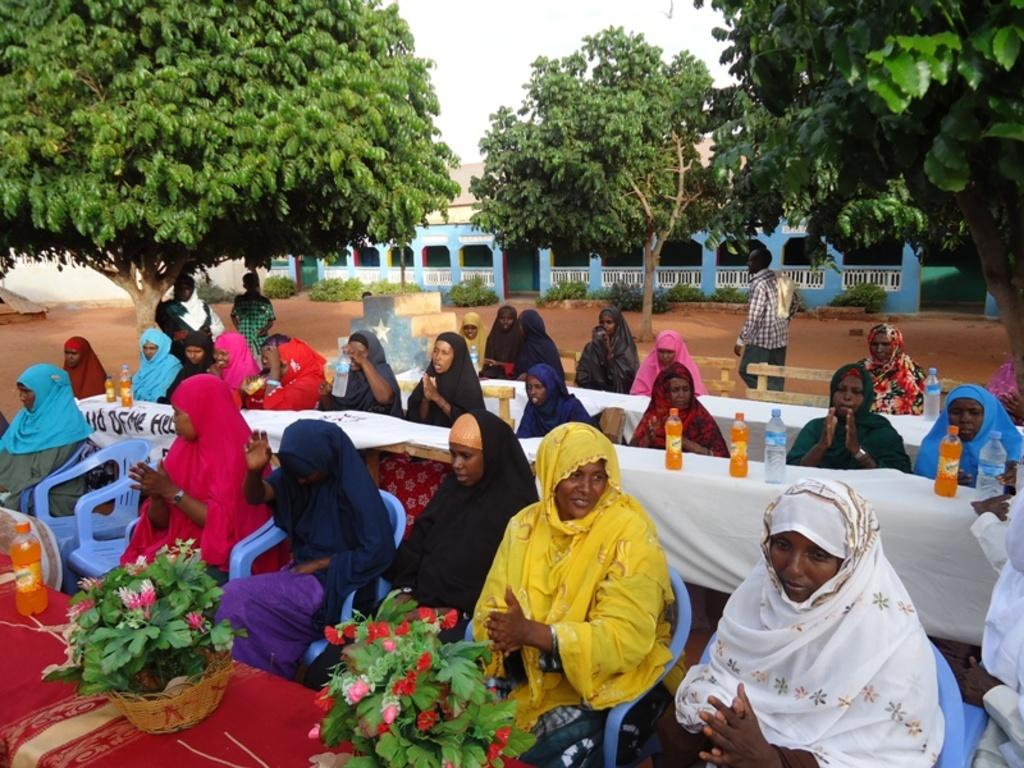What are the people in the image doing? The people in the image are sitting on chairs. What objects can be seen on the table? There are bottles, flowers, plants, and clothes on the table. What can be seen in the background of the image? In the background, there are people, trees, a house, and plants. The sky is also visible. What type of breakfast is being served on the table in the image? There is no breakfast visible in the image; the table contains bottles, flowers, plants, and clothes. What is the source of heat in the image? There is no mention of heat or any heat source in the image. 